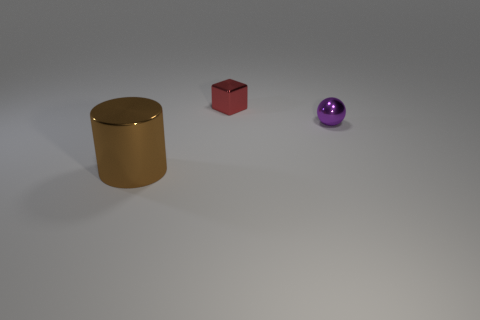Add 1 tiny red metallic things. How many objects exist? 4 Subtract all spheres. How many objects are left? 2 Add 1 tiny green metal blocks. How many tiny green metal blocks exist? 1 Subtract 0 yellow spheres. How many objects are left? 3 Subtract all cyan things. Subtract all metallic blocks. How many objects are left? 2 Add 3 tiny things. How many tiny things are left? 5 